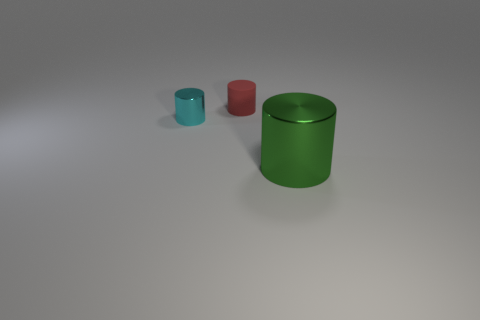Is there anything else that has the same material as the red cylinder?
Give a very brief answer. No. What material is the cylinder that is to the right of the cyan object and behind the big green object?
Provide a short and direct response. Rubber. There is a object that is in front of the tiny thing to the left of the tiny red rubber thing; what size is it?
Ensure brevity in your answer.  Large. There is a red object that is the same size as the cyan shiny cylinder; what material is it?
Offer a very short reply. Rubber. Are there fewer tiny red rubber objects that are in front of the green metal object than cyan metallic things in front of the matte cylinder?
Your response must be concise. Yes. Are any blue metal balls visible?
Keep it short and to the point. No. What color is the metallic object right of the tiny red rubber object?
Provide a short and direct response. Green. There is a big green metal object; are there any metal things on the left side of it?
Offer a terse response. Yes. Are there more red things than gray objects?
Make the answer very short. Yes. There is a metallic object that is to the left of the shiny object on the right side of the cylinder left of the red thing; what color is it?
Provide a succinct answer. Cyan. 